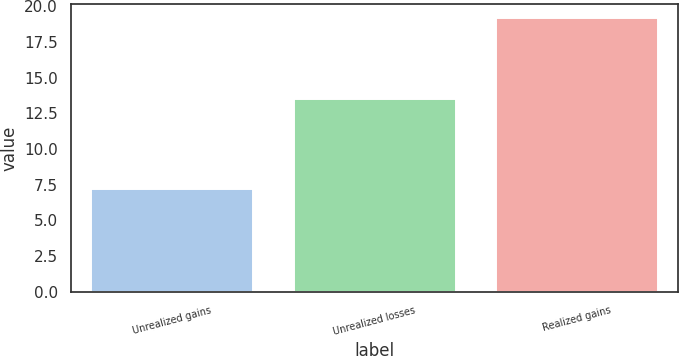Convert chart to OTSL. <chart><loc_0><loc_0><loc_500><loc_500><bar_chart><fcel>Unrealized gains<fcel>Unrealized losses<fcel>Realized gains<nl><fcel>7.2<fcel>13.5<fcel>19.2<nl></chart> 